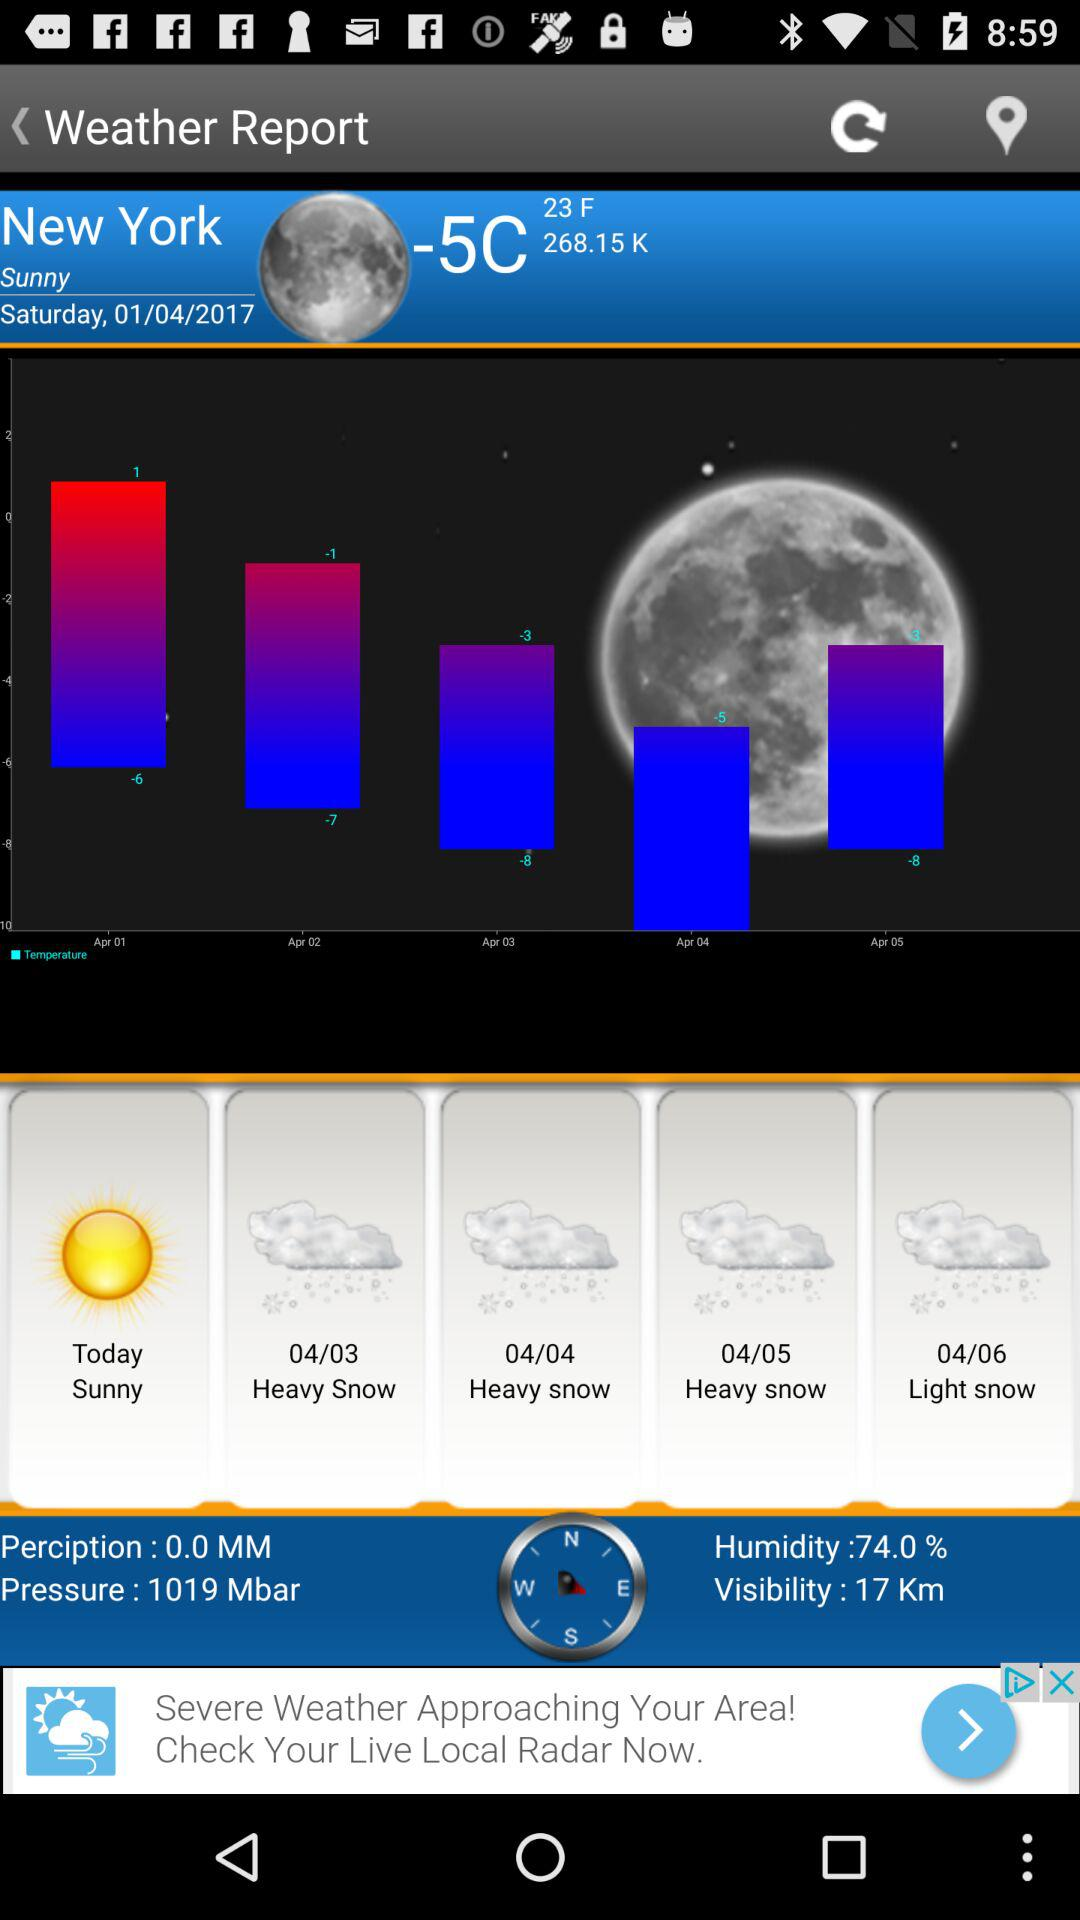What is the date? The date is January 04, 2017. 